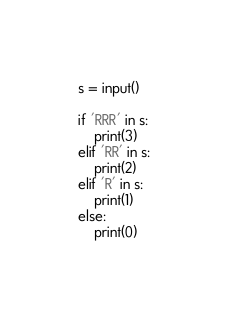Convert code to text. <code><loc_0><loc_0><loc_500><loc_500><_Python_>s = input()

if 'RRR' in s:
    print(3)
elif 'RR' in s:
    print(2)
elif 'R' in s:
    print(1)
else:
    print(0)</code> 